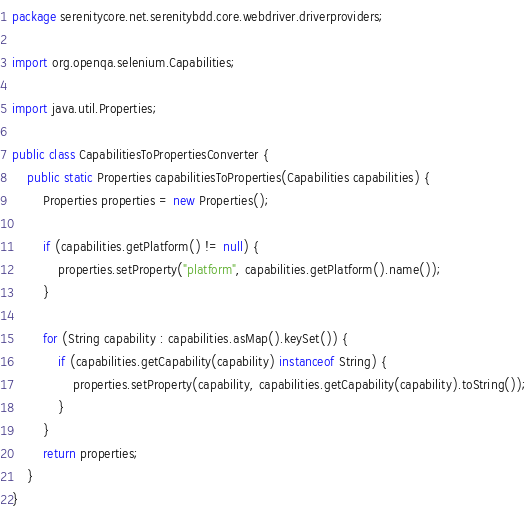<code> <loc_0><loc_0><loc_500><loc_500><_Java_>package serenitycore.net.serenitybdd.core.webdriver.driverproviders;

import org.openqa.selenium.Capabilities;

import java.util.Properties;

public class CapabilitiesToPropertiesConverter {
    public static Properties capabilitiesToProperties(Capabilities capabilities) {
        Properties properties = new Properties();

        if (capabilities.getPlatform() != null) {
            properties.setProperty("platform", capabilities.getPlatform().name());
        }

        for (String capability : capabilities.asMap().keySet()) {
            if (capabilities.getCapability(capability) instanceof String) {
                properties.setProperty(capability, capabilities.getCapability(capability).toString());
            }
        }
        return properties;
    }
}
</code> 